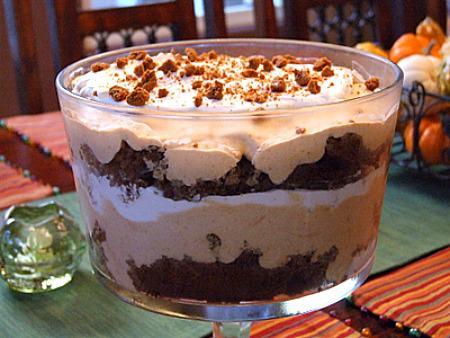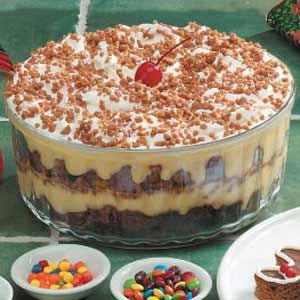The first image is the image on the left, the second image is the image on the right. Analyze the images presented: Is the assertion "There is at least one cherry with a stem in the image on the right." valid? Answer yes or no. Yes. The first image is the image on the left, the second image is the image on the right. Assess this claim about the two images: "The right image shows exactly two virtually identical trifle desserts.". Correct or not? Answer yes or no. No. 